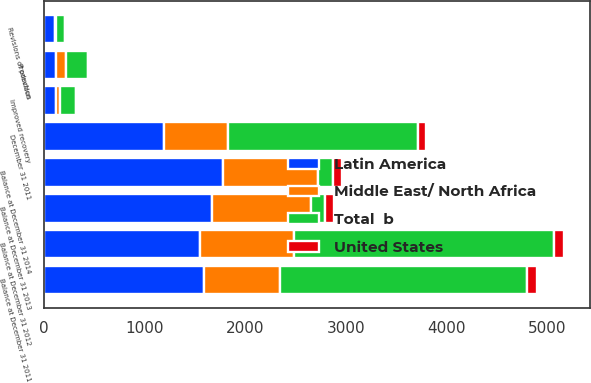Convert chart to OTSL. <chart><loc_0><loc_0><loc_500><loc_500><stacked_bar_chart><ecel><fcel>Balance at December 31 2011<fcel>Revisions of previous<fcel>Improved recovery<fcel>Production<fcel>Balance at December 31 2012<fcel>Balance at December 31 2013<fcel>Balance at December 31 2014<fcel>December 31 2011<nl><fcel>Latin America<fcel>1585<fcel>107<fcel>119<fcel>116<fcel>1551<fcel>1670<fcel>1781<fcel>1190<nl><fcel>United States<fcel>101<fcel>4<fcel>9<fcel>12<fcel>102<fcel>92<fcel>96<fcel>74<nl><fcel>Middle East/ North Africa<fcel>762<fcel>7<fcel>36<fcel>98<fcel>929<fcel>976<fcel>942<fcel>631<nl><fcel>Total  b<fcel>2448<fcel>96<fcel>164<fcel>226<fcel>2582<fcel>141.5<fcel>141.5<fcel>1895<nl></chart> 